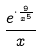<formula> <loc_0><loc_0><loc_500><loc_500>\frac { e ^ { \cdot \frac { 9 } { x ^ { 5 } } } } { x }</formula> 